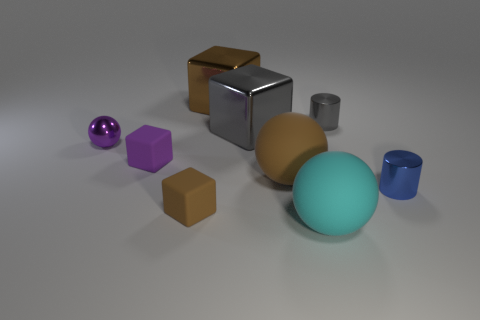Are there the same number of shiny blocks left of the tiny brown object and small purple rubber blocks?
Give a very brief answer. No. What number of balls are either large gray things or tiny brown rubber objects?
Offer a very short reply. 0. There is a small thing that is made of the same material as the tiny brown cube; what is its color?
Provide a succinct answer. Purple. Do the purple block and the brown ball behind the tiny brown cube have the same material?
Give a very brief answer. Yes. How many things are either small purple spheres or tiny yellow blocks?
Offer a terse response. 1. There is a tiny thing that is the same color as the small ball; what is its material?
Your answer should be compact. Rubber. Is there another metallic object of the same shape as the purple metallic thing?
Your answer should be very brief. No. How many cyan objects are to the left of the tiny brown block?
Ensure brevity in your answer.  0. What material is the brown block in front of the cylinder left of the tiny blue cylinder?
Your answer should be compact. Rubber. What material is the other brown thing that is the same size as the brown metal object?
Make the answer very short. Rubber. 